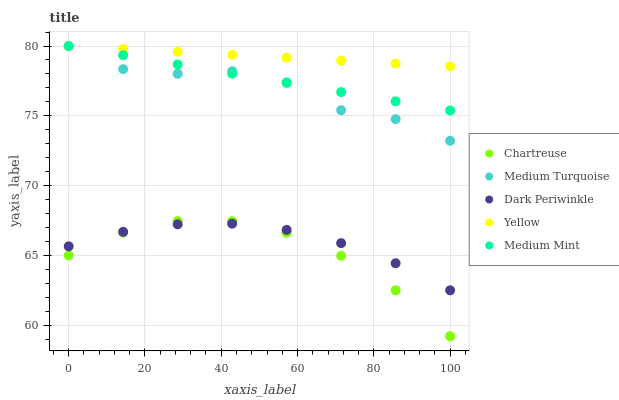Does Chartreuse have the minimum area under the curve?
Answer yes or no. Yes. Does Yellow have the maximum area under the curve?
Answer yes or no. Yes. Does Yellow have the minimum area under the curve?
Answer yes or no. No. Does Chartreuse have the maximum area under the curve?
Answer yes or no. No. Is Medium Mint the smoothest?
Answer yes or no. Yes. Is Medium Turquoise the roughest?
Answer yes or no. Yes. Is Chartreuse the smoothest?
Answer yes or no. No. Is Chartreuse the roughest?
Answer yes or no. No. Does Chartreuse have the lowest value?
Answer yes or no. Yes. Does Yellow have the lowest value?
Answer yes or no. No. Does Medium Turquoise have the highest value?
Answer yes or no. Yes. Does Chartreuse have the highest value?
Answer yes or no. No. Is Dark Periwinkle less than Medium Mint?
Answer yes or no. Yes. Is Medium Mint greater than Chartreuse?
Answer yes or no. Yes. Does Yellow intersect Medium Mint?
Answer yes or no. Yes. Is Yellow less than Medium Mint?
Answer yes or no. No. Is Yellow greater than Medium Mint?
Answer yes or no. No. Does Dark Periwinkle intersect Medium Mint?
Answer yes or no. No. 